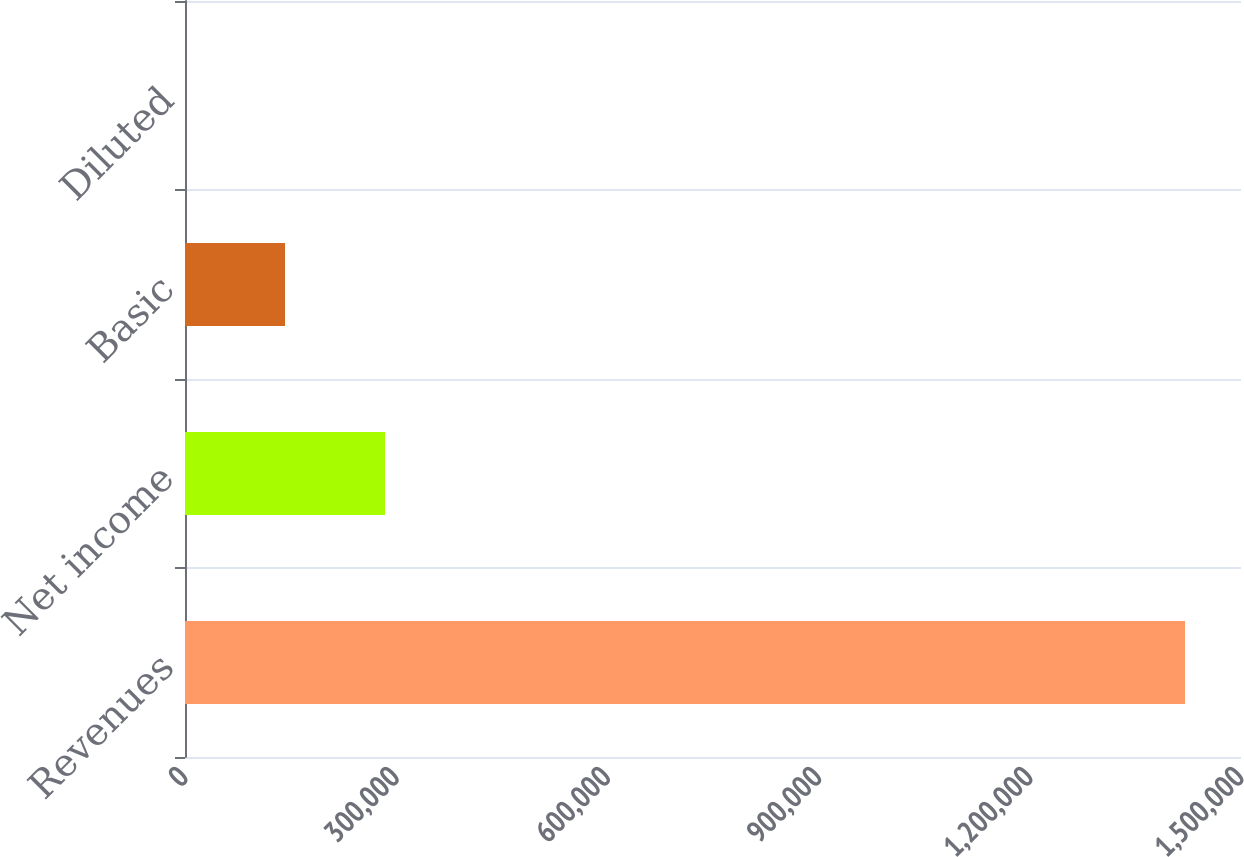Convert chart to OTSL. <chart><loc_0><loc_0><loc_500><loc_500><bar_chart><fcel>Revenues<fcel>Net income<fcel>Basic<fcel>Diluted<nl><fcel>1.4205e+06<fcel>284101<fcel>142051<fcel>0.71<nl></chart> 